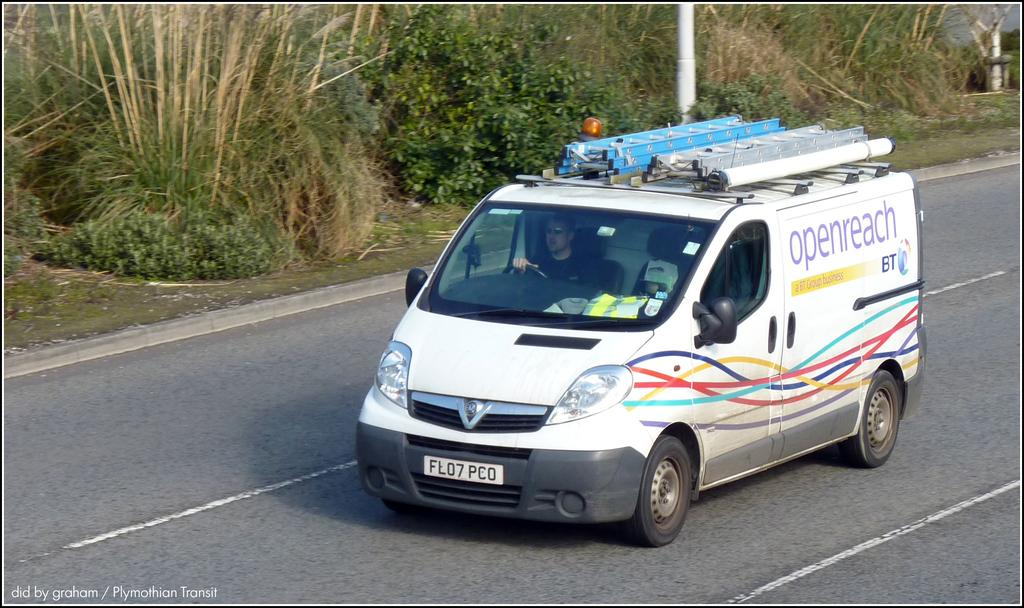What is happening in the image? There is a person inside a vehicle in the image. Where is the vehicle located? The vehicle is on a road. What can be seen in the background of the image? There are trees and a pole in the background of the image. How many children are playing with the star in the image? There is no star or children present in the image. Is there any smoke coming from the vehicle in the image? There is no smoke visible in the image. 